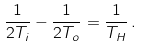<formula> <loc_0><loc_0><loc_500><loc_500>\frac { 1 } { 2 T _ { i } } - \frac { 1 } { 2 T _ { o } } = \frac { 1 } { T _ { H } } \, .</formula> 